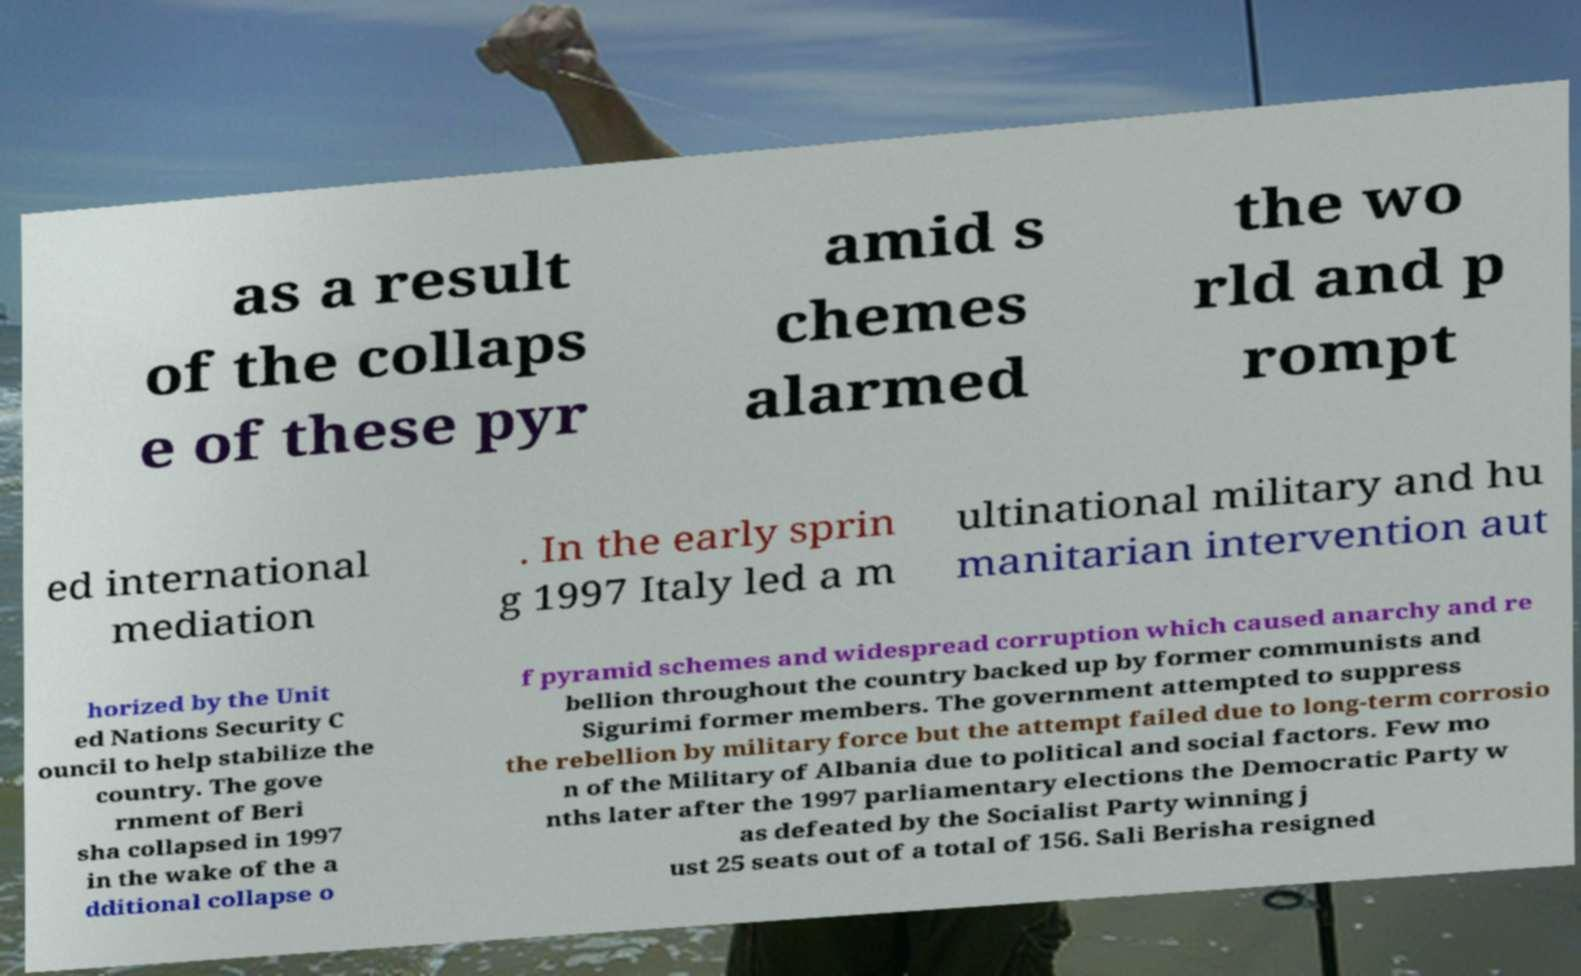Could you assist in decoding the text presented in this image and type it out clearly? as a result of the collaps e of these pyr amid s chemes alarmed the wo rld and p rompt ed international mediation . In the early sprin g 1997 Italy led a m ultinational military and hu manitarian intervention aut horized by the Unit ed Nations Security C ouncil to help stabilize the country. The gove rnment of Beri sha collapsed in 1997 in the wake of the a dditional collapse o f pyramid schemes and widespread corruption which caused anarchy and re bellion throughout the country backed up by former communists and Sigurimi former members. The government attempted to suppress the rebellion by military force but the attempt failed due to long-term corrosio n of the Military of Albania due to political and social factors. Few mo nths later after the 1997 parliamentary elections the Democratic Party w as defeated by the Socialist Party winning j ust 25 seats out of a total of 156. Sali Berisha resigned 